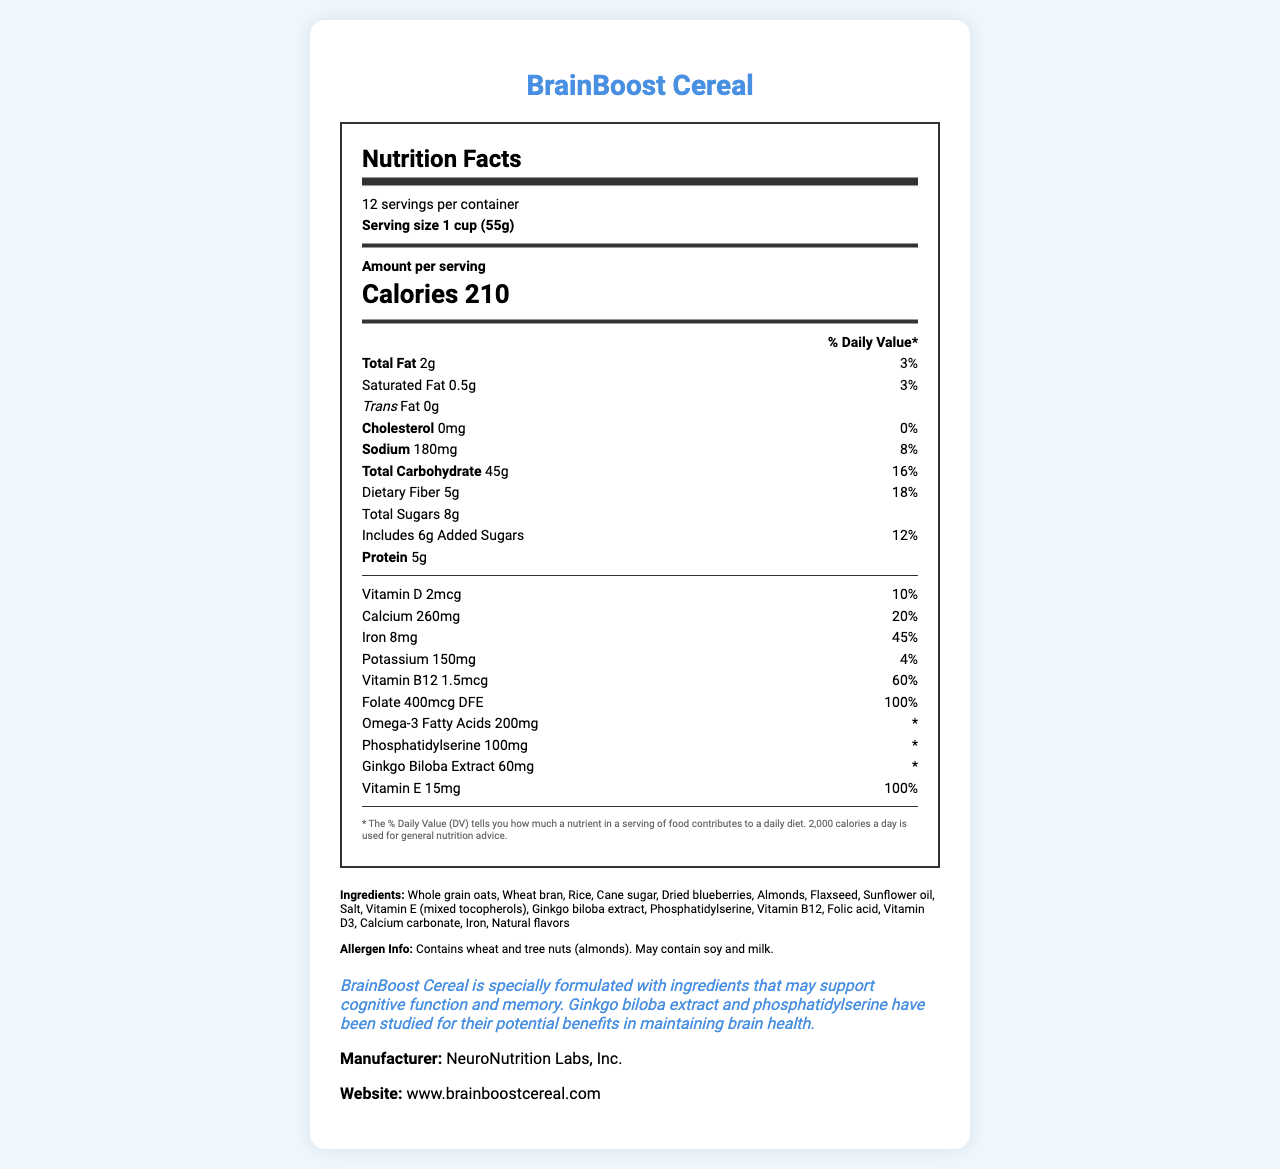what is the serving size for BrainBoost Cereal? The serving size is stated in the document as "1 cup (55g)".
Answer: 1 cup (55g) how many servings are there per container? The document specifies there are 12 servings per container.
Answer: 12 what is the total fat content per serving, and what percentage of the daily value does it represent? The document lists the total fat content as 2g per serving, which is 3% of the daily value.
Answer: 2g, 3% how much protein does each serving contain? According to the document, each serving contains 5g of protein.
Answer: 5g how much calcium is in one serving, and what percentage of the daily value does it represent? The document indicates there is 260mg of calcium per serving, accounting for 20% of the daily value.
Answer: 260mg, 20% which vitamin has the highest daily value percentage per serving? The document lists the percentage daily value of Vitamin B12 as 60%, which is the highest among the listed vitamins and minerals.
Answer: Vitamin B12 at 60% does BrainBoost Cereal contain any added sugars? The document mentions the cereal contains 6g of added sugars, which is 12% of the daily value.
Answer: Yes which ingredient is not listed in the ingredients of BrainBoost Cereal? A. Almonds B. Sunflower oil C. Honey D. Flaxseed The ingredients list contains almonds, sunflower oil, and flaxseed but not honey.
Answer: C. Honey how much sodium is in one serving, and what percentage of the daily value does it represent? The document states that one serving contains 180mg of sodium, which is 8% of the daily value.
Answer: 180mg, 8% is BrainBoost Cereal a good source of dietary fiber? A. Yes B. No C. Cannot be determined The document indicates the cereal contains 5g of dietary fiber per serving, representing 18% of the daily value, which suggests it is a good source of dietary fiber.
Answer: A. Yes does the cereal contain any allergens? The allergen information section states that the cereal contains wheat and tree nuts (almonds) and may contain soy and milk.
Answer: Yes is there any trans fat in BrainBoost Cereal? The document indicates that the cereal contains 0g of trans fat.
Answer: No summarize the main idea of the document. The document outlines the serving size, servings per container, amounts, and percentages of various nutrients and vitamins per serving. It also includes the ingredients list, allergen information, a health claim regarding cognitive support, and manufacturer details.
Answer: The document provides the nutrition facts for BrainBoost Cereal, highlighting ingredients, daily value percentages for essential nutrients, allergens, and the product's potential cognitive health benefits. can the health claim stated on the cereal box be verified with this document alone? The document mentions that BrainBoost Cereal may support cognitive function and memory, but it does not provide evidence or studies to substantiate this claim.
Answer: No 